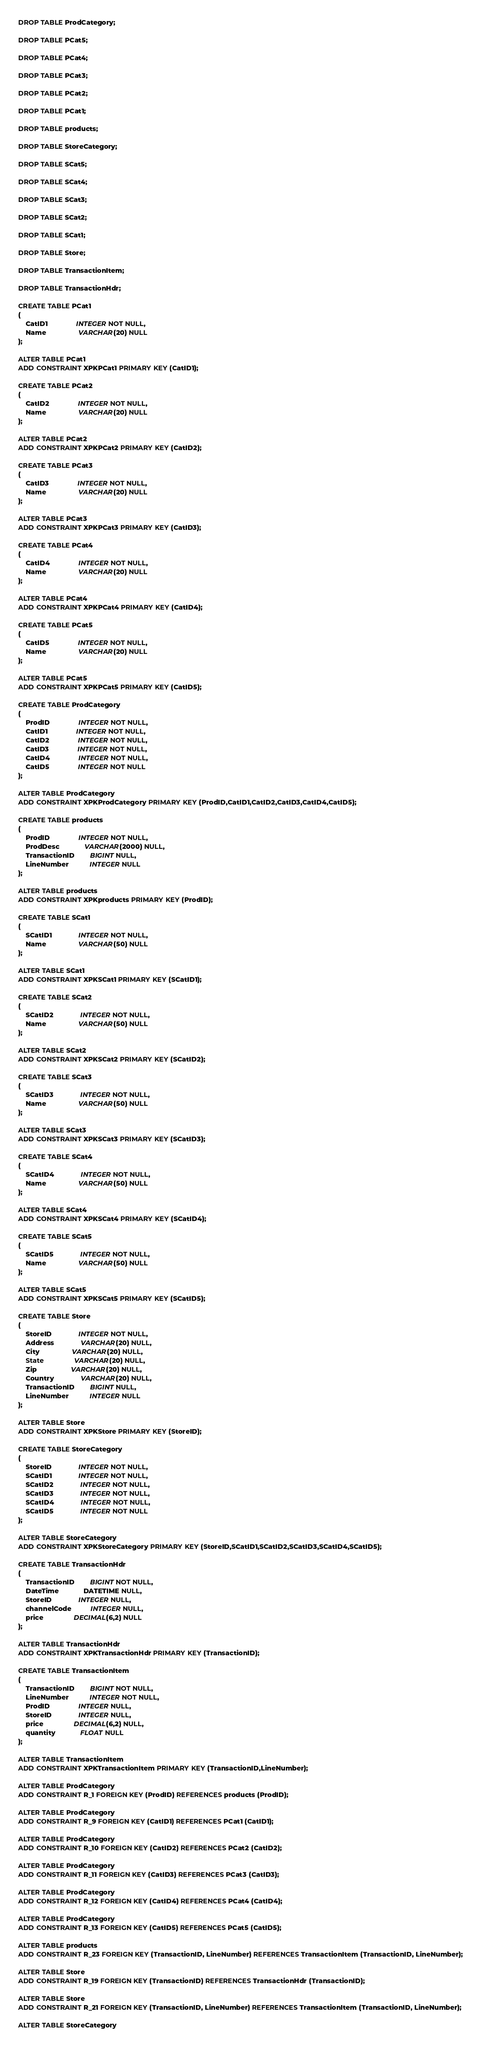Convert code to text. <code><loc_0><loc_0><loc_500><loc_500><_SQL_>
DROP TABLE ProdCategory;

DROP TABLE PCat5;

DROP TABLE PCat4;

DROP TABLE PCat3;

DROP TABLE PCat2;

DROP TABLE PCat1;

DROP TABLE products;

DROP TABLE StoreCategory;

DROP TABLE SCat5;

DROP TABLE SCat4;

DROP TABLE SCat3;

DROP TABLE SCat2;

DROP TABLE SCat1;

DROP TABLE Store;

DROP TABLE TransactionItem;

DROP TABLE TransactionHdr;

CREATE TABLE PCat1
(
	CatID1               INTEGER NOT NULL,
	Name                 VARCHAR(20) NULL
);

ALTER TABLE PCat1
ADD CONSTRAINT XPKPCat1 PRIMARY KEY (CatID1);

CREATE TABLE PCat2
(
	CatID2               INTEGER NOT NULL,
	Name                 VARCHAR(20) NULL
);

ALTER TABLE PCat2
ADD CONSTRAINT XPKPCat2 PRIMARY KEY (CatID2);

CREATE TABLE PCat3
(
	CatID3               INTEGER NOT NULL,
	Name                 VARCHAR(20) NULL
);

ALTER TABLE PCat3
ADD CONSTRAINT XPKPCat3 PRIMARY KEY (CatID3);

CREATE TABLE PCat4
(
	CatID4               INTEGER NOT NULL,
	Name                 VARCHAR(20) NULL
);

ALTER TABLE PCat4
ADD CONSTRAINT XPKPCat4 PRIMARY KEY (CatID4);

CREATE TABLE PCat5
(
	CatID5               INTEGER NOT NULL,
	Name                 VARCHAR(20) NULL
);

ALTER TABLE PCat5
ADD CONSTRAINT XPKPCat5 PRIMARY KEY (CatID5);

CREATE TABLE ProdCategory
(
	ProdID               INTEGER NOT NULL,
	CatID1               INTEGER NOT NULL,
	CatID2               INTEGER NOT NULL,
	CatID3               INTEGER NOT NULL,
	CatID4               INTEGER NOT NULL,
	CatID5               INTEGER NOT NULL
);

ALTER TABLE ProdCategory
ADD CONSTRAINT XPKProdCategory PRIMARY KEY (ProdID,CatID1,CatID2,CatID3,CatID4,CatID5);

CREATE TABLE products
(
	ProdID               INTEGER NOT NULL,
	ProdDesc             VARCHAR(2000) NULL,
	TransactionID        BIGINT NULL,
	LineNumber           INTEGER NULL
);

ALTER TABLE products
ADD CONSTRAINT XPKproducts PRIMARY KEY (ProdID);

CREATE TABLE SCat1
(
	SCatID1              INTEGER NOT NULL,
	Name                 VARCHAR(50) NULL
);

ALTER TABLE SCat1
ADD CONSTRAINT XPKSCat1 PRIMARY KEY (SCatID1);

CREATE TABLE SCat2
(
	SCatID2              INTEGER NOT NULL,
	Name                 VARCHAR(50) NULL
);

ALTER TABLE SCat2
ADD CONSTRAINT XPKSCat2 PRIMARY KEY (SCatID2);

CREATE TABLE SCat3
(
	SCatID3              INTEGER NOT NULL,
	Name                 VARCHAR(50) NULL
);

ALTER TABLE SCat3
ADD CONSTRAINT XPKSCat3 PRIMARY KEY (SCatID3);

CREATE TABLE SCat4
(
	SCatID4              INTEGER NOT NULL,
	Name                 VARCHAR(50) NULL
);

ALTER TABLE SCat4
ADD CONSTRAINT XPKSCat4 PRIMARY KEY (SCatID4);

CREATE TABLE SCat5
(
	SCatID5              INTEGER NOT NULL,
	Name                 VARCHAR(50) NULL
);

ALTER TABLE SCat5
ADD CONSTRAINT XPKSCat5 PRIMARY KEY (SCatID5);

CREATE TABLE Store
(
	StoreID              INTEGER NOT NULL,
	Address              VARCHAR(20) NULL,
	City                 VARCHAR(20) NULL,
	State                VARCHAR(20) NULL,
	Zip                  VARCHAR(20) NULL,
	Country              VARCHAR(20) NULL,
	TransactionID        BIGINT NULL,
	LineNumber           INTEGER NULL
);

ALTER TABLE Store
ADD CONSTRAINT XPKStore PRIMARY KEY (StoreID);

CREATE TABLE StoreCategory
(
	StoreID              INTEGER NOT NULL,
	SCatID1              INTEGER NOT NULL,
	SCatID2              INTEGER NOT NULL,
	SCatID3              INTEGER NOT NULL,
	SCatID4              INTEGER NOT NULL,
	SCatID5              INTEGER NOT NULL
);

ALTER TABLE StoreCategory
ADD CONSTRAINT XPKStoreCategory PRIMARY KEY (StoreID,SCatID1,SCatID2,SCatID3,SCatID4,SCatID5);

CREATE TABLE TransactionHdr
(
	TransactionID        BIGINT NOT NULL,
	DateTime             DATETIME NULL,
	StoreID              INTEGER NULL,
	channelCode          INTEGER NULL,
	price                DECIMAL(6,2) NULL
);

ALTER TABLE TransactionHdr
ADD CONSTRAINT XPKTransactionHdr PRIMARY KEY (TransactionID);

CREATE TABLE TransactionItem
(
	TransactionID        BIGINT NOT NULL,
	LineNumber           INTEGER NOT NULL,
	ProdID               INTEGER NULL,
	StoreID              INTEGER NULL,
	price                DECIMAL(6,2) NULL,
	quantity             FLOAT NULL
);

ALTER TABLE TransactionItem
ADD CONSTRAINT XPKTransactionItem PRIMARY KEY (TransactionID,LineNumber);

ALTER TABLE ProdCategory
ADD CONSTRAINT R_1 FOREIGN KEY (ProdID) REFERENCES products (ProdID);

ALTER TABLE ProdCategory
ADD CONSTRAINT R_9 FOREIGN KEY (CatID1) REFERENCES PCat1 (CatID1);

ALTER TABLE ProdCategory
ADD CONSTRAINT R_10 FOREIGN KEY (CatID2) REFERENCES PCat2 (CatID2);

ALTER TABLE ProdCategory
ADD CONSTRAINT R_11 FOREIGN KEY (CatID3) REFERENCES PCat3 (CatID3);

ALTER TABLE ProdCategory
ADD CONSTRAINT R_12 FOREIGN KEY (CatID4) REFERENCES PCat4 (CatID4);

ALTER TABLE ProdCategory
ADD CONSTRAINT R_13 FOREIGN KEY (CatID5) REFERENCES PCat5 (CatID5);

ALTER TABLE products
ADD CONSTRAINT R_23 FOREIGN KEY (TransactionID, LineNumber) REFERENCES TransactionItem (TransactionID, LineNumber);

ALTER TABLE Store
ADD CONSTRAINT R_19 FOREIGN KEY (TransactionID) REFERENCES TransactionHdr (TransactionID);

ALTER TABLE Store
ADD CONSTRAINT R_21 FOREIGN KEY (TransactionID, LineNumber) REFERENCES TransactionItem (TransactionID, LineNumber);

ALTER TABLE StoreCategory</code> 